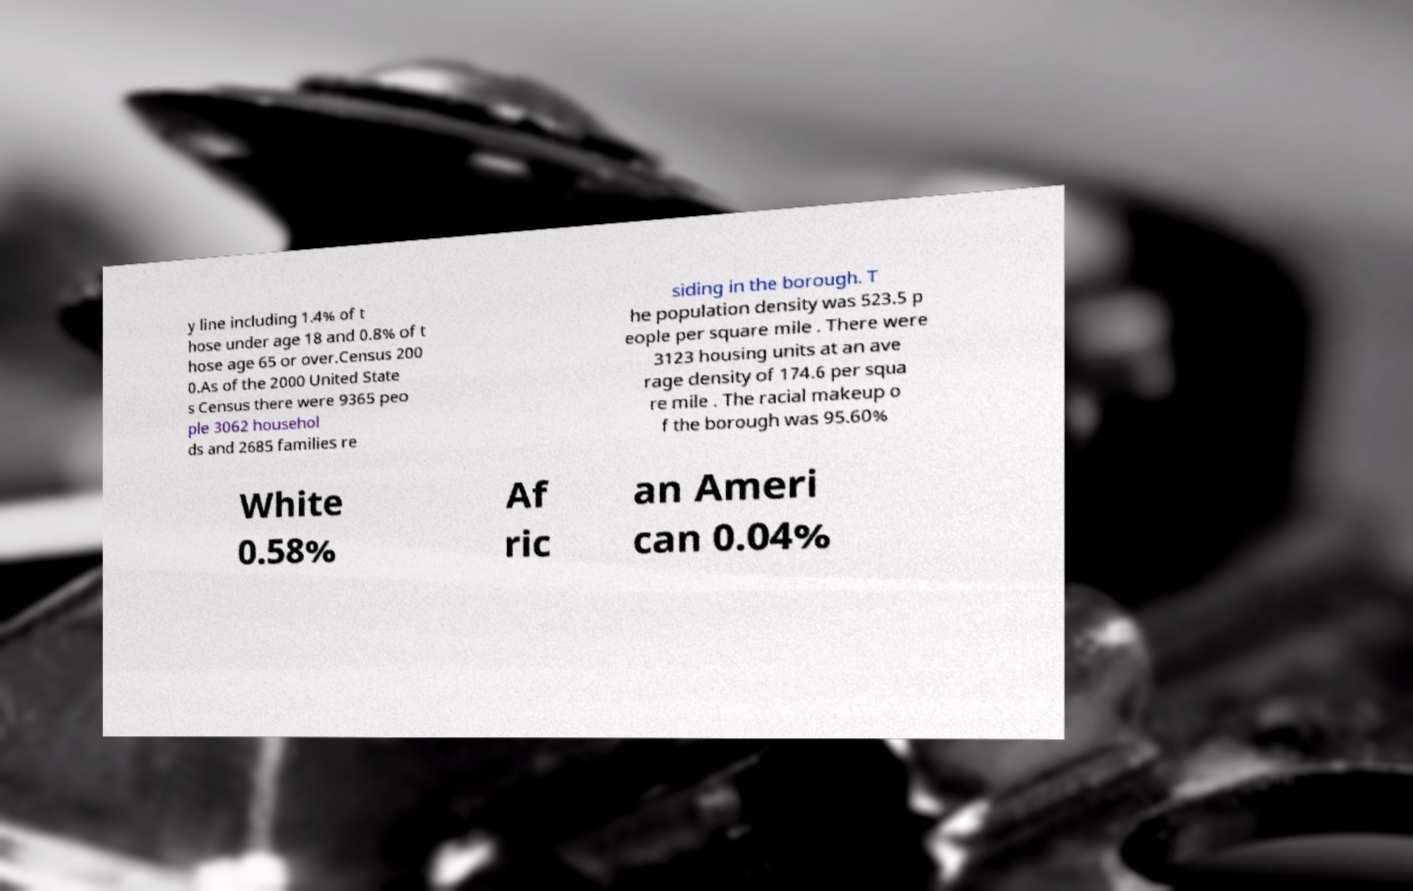Could you assist in decoding the text presented in this image and type it out clearly? y line including 1.4% of t hose under age 18 and 0.8% of t hose age 65 or over.Census 200 0.As of the 2000 United State s Census there were 9365 peo ple 3062 househol ds and 2685 families re siding in the borough. T he population density was 523.5 p eople per square mile . There were 3123 housing units at an ave rage density of 174.6 per squa re mile . The racial makeup o f the borough was 95.60% White 0.58% Af ric an Ameri can 0.04% 